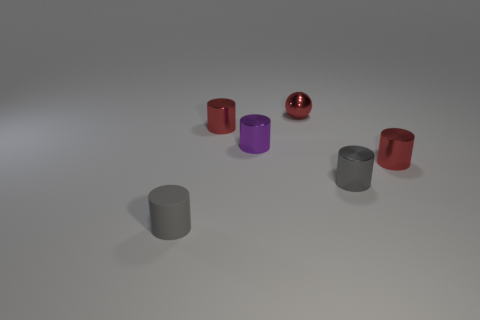Subtract 1 cylinders. How many cylinders are left? 4 Subtract all blue balls. Subtract all purple blocks. How many balls are left? 1 Add 3 gray cylinders. How many objects exist? 9 Subtract all spheres. How many objects are left? 5 Add 4 small blue things. How many small blue things exist? 4 Subtract 0 yellow blocks. How many objects are left? 6 Subtract all small rubber balls. Subtract all matte objects. How many objects are left? 5 Add 6 small gray shiny things. How many small gray shiny things are left? 7 